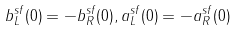<formula> <loc_0><loc_0><loc_500><loc_500>b ^ { s f } _ { L } ( 0 ) = - b ^ { s f } _ { R } ( 0 ) , a ^ { s f } _ { L } ( 0 ) = - a ^ { s f } _ { R } ( 0 )</formula> 